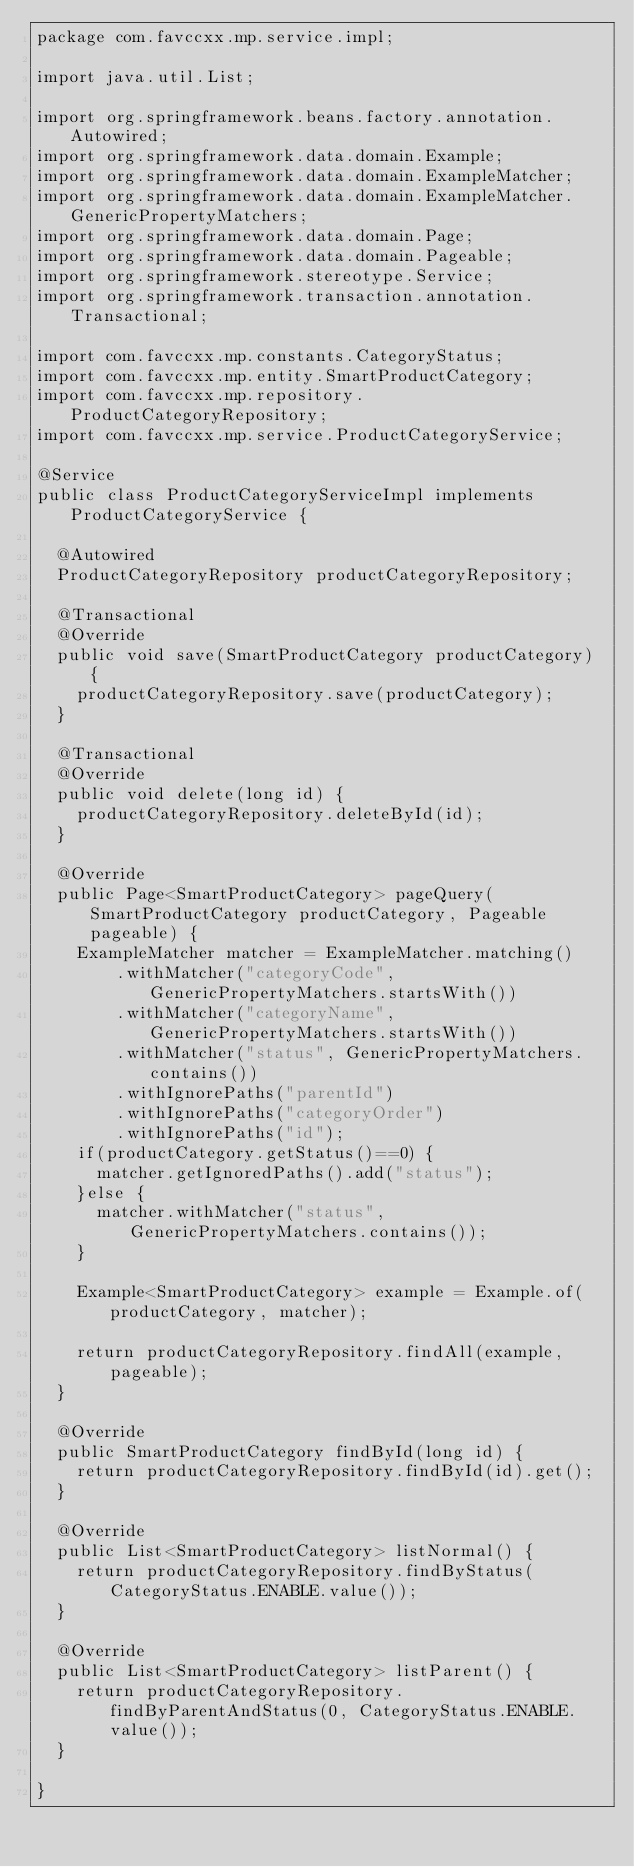<code> <loc_0><loc_0><loc_500><loc_500><_Java_>package com.favccxx.mp.service.impl;

import java.util.List;

import org.springframework.beans.factory.annotation.Autowired;
import org.springframework.data.domain.Example;
import org.springframework.data.domain.ExampleMatcher;
import org.springframework.data.domain.ExampleMatcher.GenericPropertyMatchers;
import org.springframework.data.domain.Page;
import org.springframework.data.domain.Pageable;
import org.springframework.stereotype.Service;
import org.springframework.transaction.annotation.Transactional;

import com.favccxx.mp.constants.CategoryStatus;
import com.favccxx.mp.entity.SmartProductCategory;
import com.favccxx.mp.repository.ProductCategoryRepository;
import com.favccxx.mp.service.ProductCategoryService;

@Service
public class ProductCategoryServiceImpl implements ProductCategoryService {
	
	@Autowired
	ProductCategoryRepository productCategoryRepository;

	@Transactional
	@Override
	public void save(SmartProductCategory productCategory) {
		productCategoryRepository.save(productCategory);
	}

	@Transactional
	@Override
	public void delete(long id) {		
		productCategoryRepository.deleteById(id);
	}

	@Override
	public Page<SmartProductCategory> pageQuery(SmartProductCategory productCategory, Pageable pageable) {
		ExampleMatcher matcher = ExampleMatcher.matching()
				.withMatcher("categoryCode", GenericPropertyMatchers.startsWith())
				.withMatcher("categoryName", GenericPropertyMatchers.startsWith())
				.withMatcher("status", GenericPropertyMatchers.contains())
				.withIgnorePaths("parentId")
				.withIgnorePaths("categoryOrder")
				.withIgnorePaths("id");
		if(productCategory.getStatus()==0) {
			matcher.getIgnoredPaths().add("status");
		}else {
			matcher.withMatcher("status", GenericPropertyMatchers.contains());
		}

		Example<SmartProductCategory> example = Example.of(productCategory, matcher);

		return productCategoryRepository.findAll(example, pageable);
	}

	@Override
	public SmartProductCategory findById(long id) {
		return productCategoryRepository.findById(id).get();
	}

	@Override
	public List<SmartProductCategory> listNormal() {		
		return productCategoryRepository.findByStatus(CategoryStatus.ENABLE.value());
	}

	@Override
	public List<SmartProductCategory> listParent() {
		return productCategoryRepository.findByParentAndStatus(0, CategoryStatus.ENABLE.value());
	}

}
</code> 